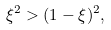Convert formula to latex. <formula><loc_0><loc_0><loc_500><loc_500>\xi ^ { 2 } > ( 1 - \xi ) ^ { 2 } ,</formula> 